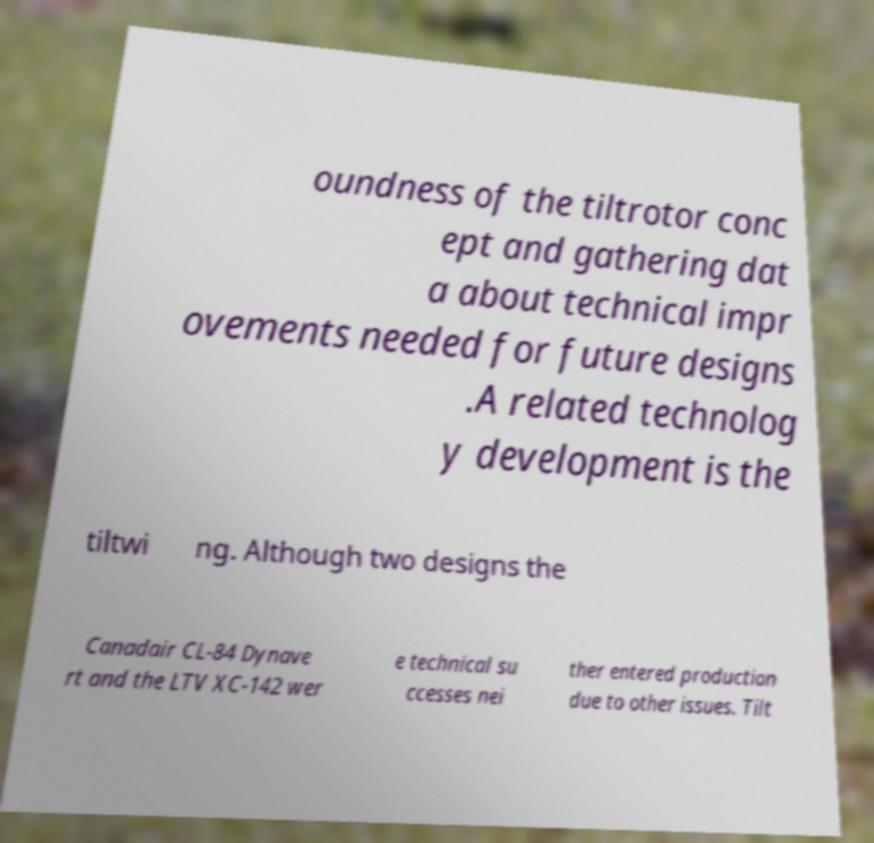For documentation purposes, I need the text within this image transcribed. Could you provide that? oundness of the tiltrotor conc ept and gathering dat a about technical impr ovements needed for future designs .A related technolog y development is the tiltwi ng. Although two designs the Canadair CL-84 Dynave rt and the LTV XC-142 wer e technical su ccesses nei ther entered production due to other issues. Tilt 